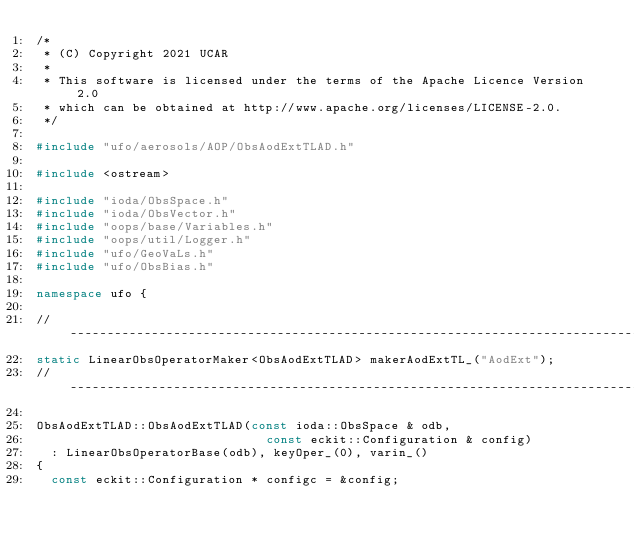<code> <loc_0><loc_0><loc_500><loc_500><_C++_>/*
 * (C) Copyright 2021 UCAR
 *
 * This software is licensed under the terms of the Apache Licence Version 2.0
 * which can be obtained at http://www.apache.org/licenses/LICENSE-2.0.
 */

#include "ufo/aerosols/AOP/ObsAodExtTLAD.h"

#include <ostream>

#include "ioda/ObsSpace.h"
#include "ioda/ObsVector.h"
#include "oops/base/Variables.h"
#include "oops/util/Logger.h"
#include "ufo/GeoVaLs.h"
#include "ufo/ObsBias.h"

namespace ufo {

// -----------------------------------------------------------------------------
static LinearObsOperatorMaker<ObsAodExtTLAD> makerAodExtTL_("AodExt");
// -----------------------------------------------------------------------------

ObsAodExtTLAD::ObsAodExtTLAD(const ioda::ObsSpace & odb,
                               const eckit::Configuration & config)
  : LinearObsOperatorBase(odb), keyOper_(0), varin_()
{
  const eckit::Configuration * configc = &config;
</code> 